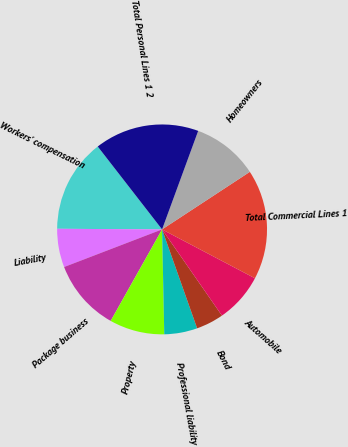Convert chart to OTSL. <chart><loc_0><loc_0><loc_500><loc_500><pie_chart><fcel>Workers' compensation<fcel>Liability<fcel>Package business<fcel>Property<fcel>Professional liability<fcel>Bond<fcel>Automobile<fcel>Total Commercial Lines 1<fcel>Homeowners<fcel>Total Personal Lines 1 2<nl><fcel>14.4%<fcel>5.93%<fcel>11.02%<fcel>8.48%<fcel>5.09%<fcel>4.24%<fcel>7.63%<fcel>16.95%<fcel>10.17%<fcel>16.1%<nl></chart> 